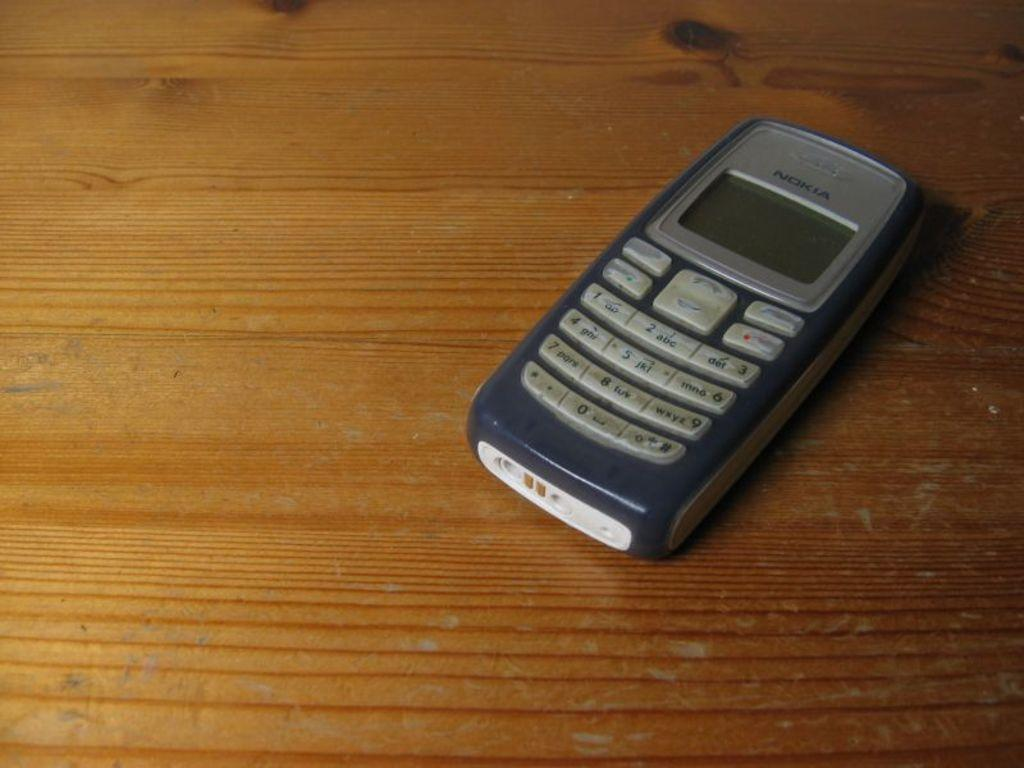<image>
Describe the image concisely. A Nokia cell phone lays on a wood table. 